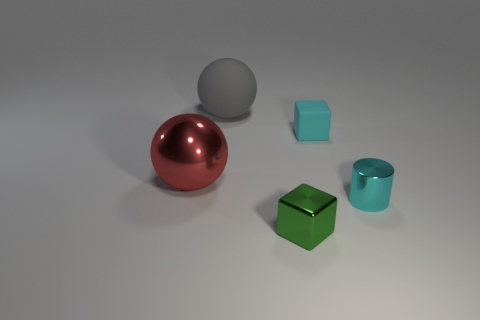Subtract all green cubes. How many cubes are left? 1 Add 1 rubber spheres. How many objects exist? 6 Subtract all spheres. How many objects are left? 3 Subtract 2 spheres. How many spheres are left? 0 Subtract 0 cyan balls. How many objects are left? 5 Subtract all blue balls. Subtract all green cylinders. How many balls are left? 2 Subtract all blue cylinders. How many green spheres are left? 0 Subtract all big gray rubber cylinders. Subtract all tiny matte objects. How many objects are left? 4 Add 4 small metallic objects. How many small metallic objects are left? 6 Add 4 small matte blocks. How many small matte blocks exist? 5 